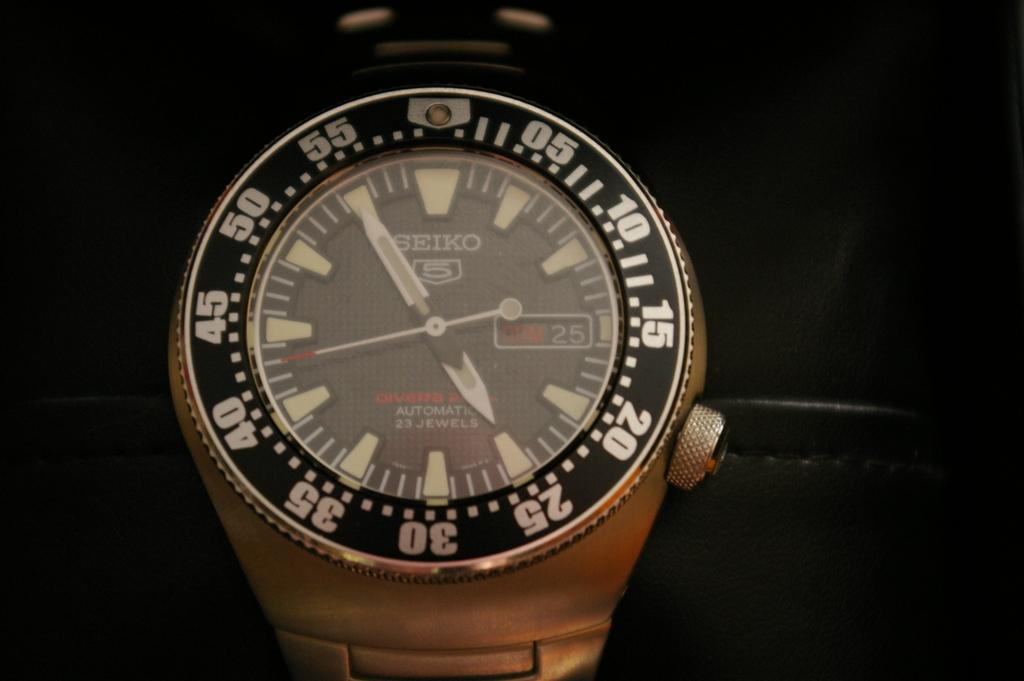<image>
Relay a brief, clear account of the picture shown. A Seiko watch on a very dark background 